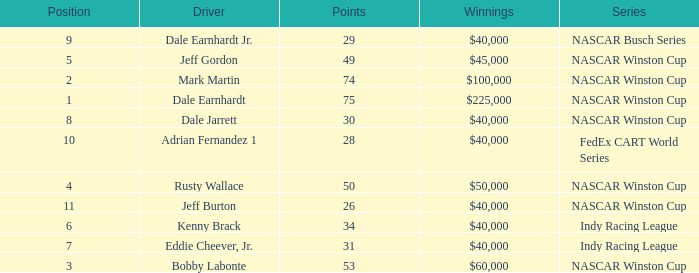What position did the driver earn 31 points? 7.0. 